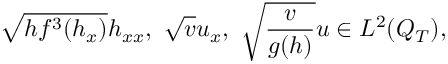<formula> <loc_0><loc_0><loc_500><loc_500>\sqrt { h f ^ { 3 } ( h _ { x } ) } h _ { x x } , \ \sqrt { v } u _ { x } , \ \sqrt { \frac { v } { g ( h ) } } u \in L ^ { 2 } ( Q _ { T } ) ,</formula> 